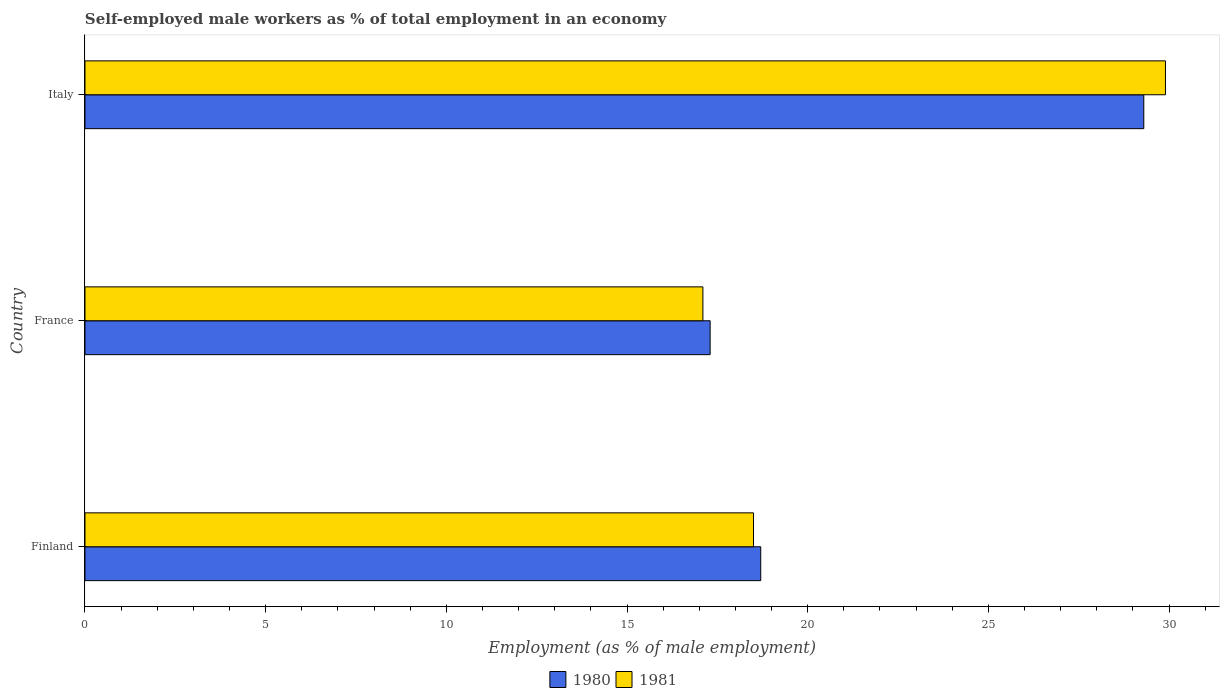Are the number of bars per tick equal to the number of legend labels?
Provide a succinct answer. Yes. Are the number of bars on each tick of the Y-axis equal?
Provide a succinct answer. Yes. How many bars are there on the 2nd tick from the top?
Offer a very short reply. 2. How many bars are there on the 1st tick from the bottom?
Provide a short and direct response. 2. What is the label of the 2nd group of bars from the top?
Make the answer very short. France. What is the percentage of self-employed male workers in 1981 in Finland?
Make the answer very short. 18.5. Across all countries, what is the maximum percentage of self-employed male workers in 1980?
Your response must be concise. 29.3. Across all countries, what is the minimum percentage of self-employed male workers in 1980?
Keep it short and to the point. 17.3. In which country was the percentage of self-employed male workers in 1980 maximum?
Your answer should be compact. Italy. In which country was the percentage of self-employed male workers in 1980 minimum?
Give a very brief answer. France. What is the total percentage of self-employed male workers in 1980 in the graph?
Your answer should be compact. 65.3. What is the difference between the percentage of self-employed male workers in 1980 in Italy and the percentage of self-employed male workers in 1981 in France?
Your answer should be very brief. 12.2. What is the average percentage of self-employed male workers in 1981 per country?
Ensure brevity in your answer.  21.83. What is the difference between the percentage of self-employed male workers in 1980 and percentage of self-employed male workers in 1981 in France?
Your answer should be very brief. 0.2. What is the ratio of the percentage of self-employed male workers in 1981 in France to that in Italy?
Provide a short and direct response. 0.57. Is the difference between the percentage of self-employed male workers in 1980 in France and Italy greater than the difference between the percentage of self-employed male workers in 1981 in France and Italy?
Make the answer very short. Yes. What is the difference between the highest and the second highest percentage of self-employed male workers in 1980?
Provide a succinct answer. 10.6. Is the sum of the percentage of self-employed male workers in 1980 in Finland and Italy greater than the maximum percentage of self-employed male workers in 1981 across all countries?
Your response must be concise. Yes. Are all the bars in the graph horizontal?
Ensure brevity in your answer.  Yes. What is the difference between two consecutive major ticks on the X-axis?
Ensure brevity in your answer.  5. Are the values on the major ticks of X-axis written in scientific E-notation?
Offer a terse response. No. Does the graph contain any zero values?
Offer a very short reply. No. Where does the legend appear in the graph?
Offer a very short reply. Bottom center. How are the legend labels stacked?
Your answer should be very brief. Horizontal. What is the title of the graph?
Keep it short and to the point. Self-employed male workers as % of total employment in an economy. Does "1983" appear as one of the legend labels in the graph?
Your answer should be compact. No. What is the label or title of the X-axis?
Make the answer very short. Employment (as % of male employment). What is the label or title of the Y-axis?
Keep it short and to the point. Country. What is the Employment (as % of male employment) in 1980 in Finland?
Offer a very short reply. 18.7. What is the Employment (as % of male employment) in 1981 in Finland?
Your answer should be compact. 18.5. What is the Employment (as % of male employment) of 1980 in France?
Ensure brevity in your answer.  17.3. What is the Employment (as % of male employment) in 1981 in France?
Offer a very short reply. 17.1. What is the Employment (as % of male employment) of 1980 in Italy?
Your answer should be compact. 29.3. What is the Employment (as % of male employment) in 1981 in Italy?
Your answer should be compact. 29.9. Across all countries, what is the maximum Employment (as % of male employment) of 1980?
Make the answer very short. 29.3. Across all countries, what is the maximum Employment (as % of male employment) of 1981?
Your answer should be compact. 29.9. Across all countries, what is the minimum Employment (as % of male employment) of 1980?
Keep it short and to the point. 17.3. Across all countries, what is the minimum Employment (as % of male employment) of 1981?
Offer a very short reply. 17.1. What is the total Employment (as % of male employment) in 1980 in the graph?
Ensure brevity in your answer.  65.3. What is the total Employment (as % of male employment) of 1981 in the graph?
Keep it short and to the point. 65.5. What is the difference between the Employment (as % of male employment) of 1981 in Finland and that in France?
Provide a succinct answer. 1.4. What is the difference between the Employment (as % of male employment) of 1980 in Finland and that in Italy?
Keep it short and to the point. -10.6. What is the difference between the Employment (as % of male employment) in 1981 in Finland and that in Italy?
Your answer should be compact. -11.4. What is the difference between the Employment (as % of male employment) in 1980 in Finland and the Employment (as % of male employment) in 1981 in Italy?
Provide a short and direct response. -11.2. What is the difference between the Employment (as % of male employment) of 1980 in France and the Employment (as % of male employment) of 1981 in Italy?
Offer a terse response. -12.6. What is the average Employment (as % of male employment) in 1980 per country?
Provide a succinct answer. 21.77. What is the average Employment (as % of male employment) of 1981 per country?
Ensure brevity in your answer.  21.83. What is the ratio of the Employment (as % of male employment) in 1980 in Finland to that in France?
Offer a terse response. 1.08. What is the ratio of the Employment (as % of male employment) of 1981 in Finland to that in France?
Offer a terse response. 1.08. What is the ratio of the Employment (as % of male employment) in 1980 in Finland to that in Italy?
Provide a short and direct response. 0.64. What is the ratio of the Employment (as % of male employment) of 1981 in Finland to that in Italy?
Your answer should be compact. 0.62. What is the ratio of the Employment (as % of male employment) of 1980 in France to that in Italy?
Your response must be concise. 0.59. What is the ratio of the Employment (as % of male employment) of 1981 in France to that in Italy?
Ensure brevity in your answer.  0.57. What is the difference between the highest and the second highest Employment (as % of male employment) in 1981?
Offer a very short reply. 11.4. What is the difference between the highest and the lowest Employment (as % of male employment) of 1980?
Your answer should be very brief. 12. 